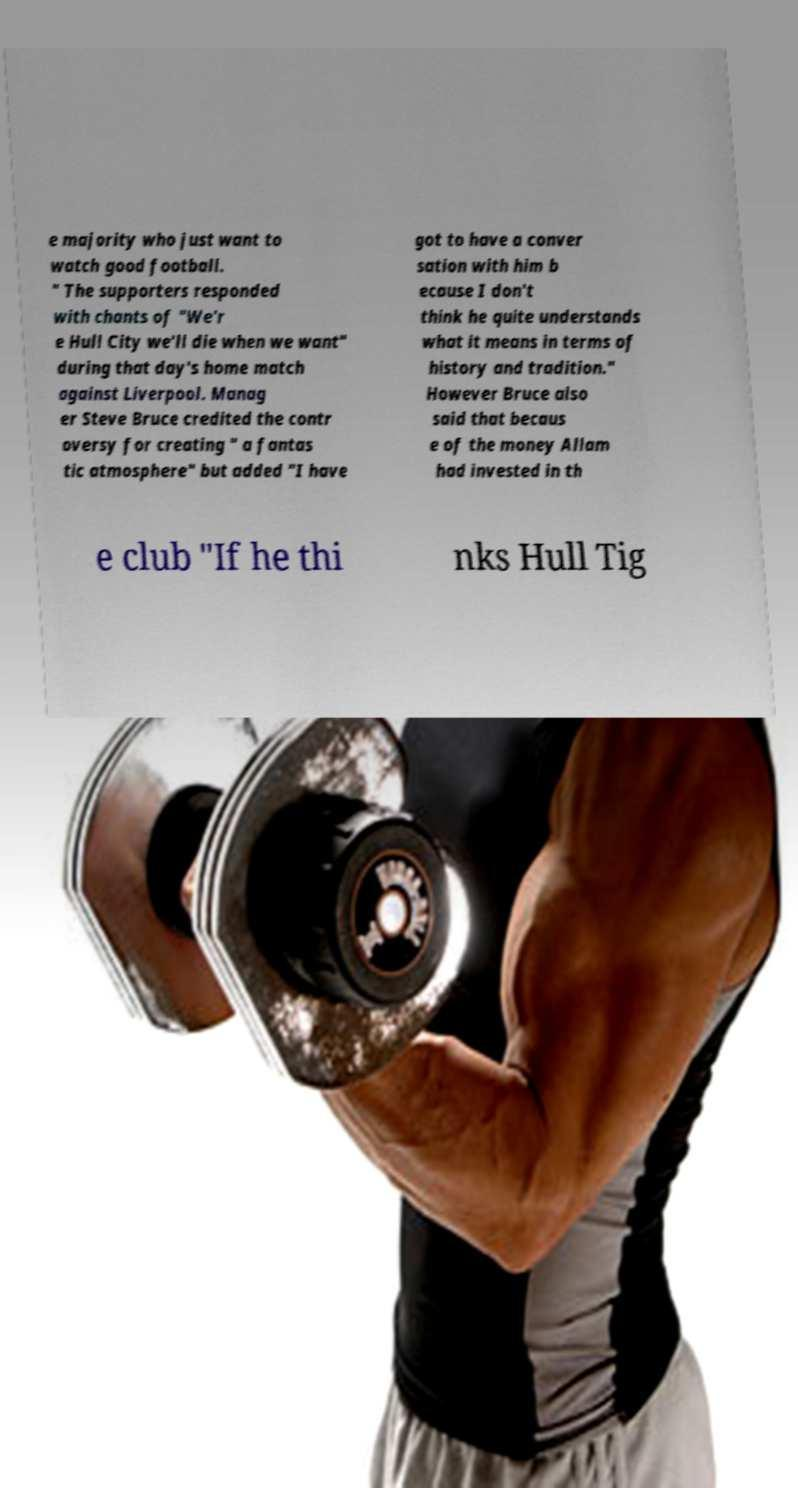Could you extract and type out the text from this image? e majority who just want to watch good football. " The supporters responded with chants of "We'r e Hull City we'll die when we want" during that day's home match against Liverpool. Manag er Steve Bruce credited the contr oversy for creating " a fantas tic atmosphere" but added "I have got to have a conver sation with him b ecause I don't think he quite understands what it means in terms of history and tradition." However Bruce also said that becaus e of the money Allam had invested in th e club "If he thi nks Hull Tig 